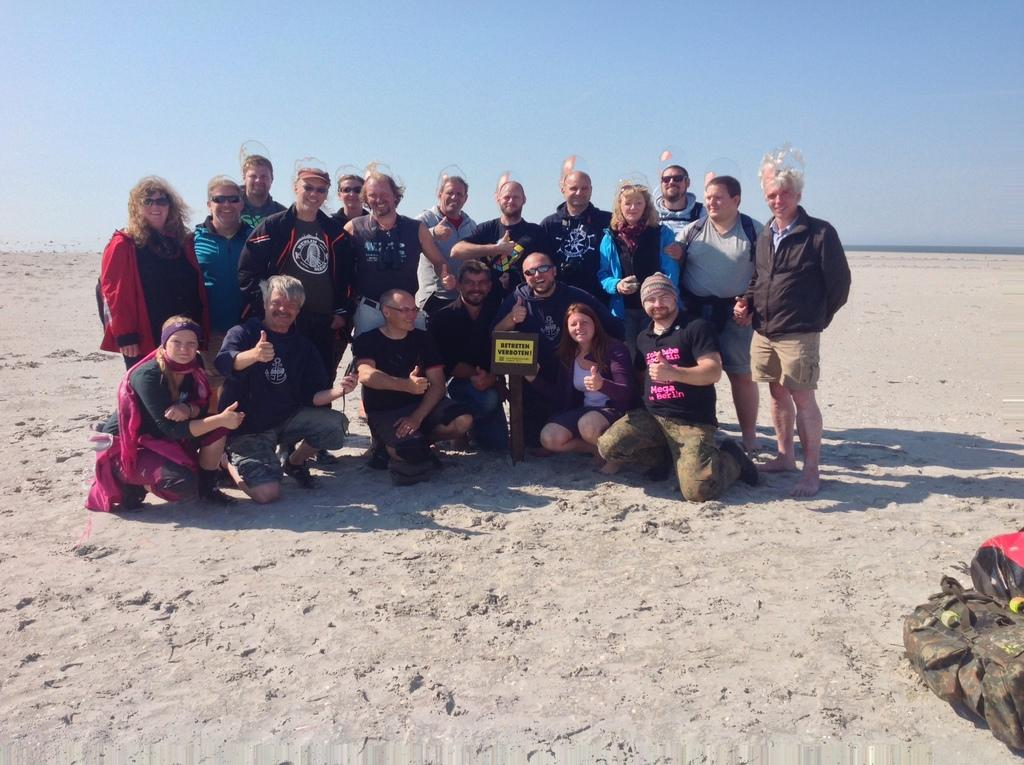What are the people in the image doing? There are people sitting on the sand and standing in the image. What can be seen in the image besides the people? There is a board and an object visible in the image. What is visible at the top of the image? The sky is visible at the top of the image. What type of paste is being used by the people in the image? There is no paste present in the image; the people are sitting on the sand and standing. How many elbows can be seen in the image? The number of elbows cannot be determined from the image, as it focuses on the people's overall posture and positioning. 